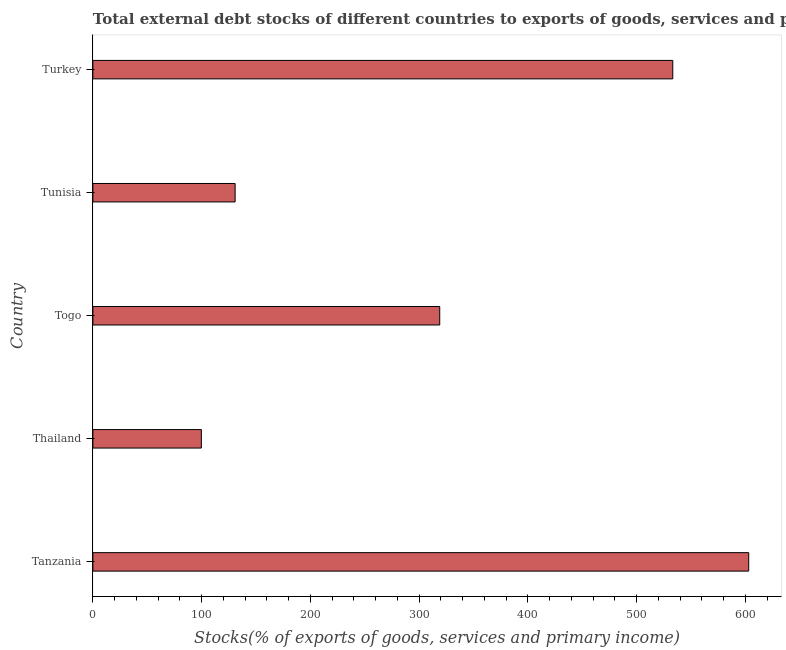Does the graph contain any zero values?
Your answer should be compact. No. What is the title of the graph?
Offer a very short reply. Total external debt stocks of different countries to exports of goods, services and primary income in 1979. What is the label or title of the X-axis?
Keep it short and to the point. Stocks(% of exports of goods, services and primary income). What is the label or title of the Y-axis?
Make the answer very short. Country. What is the external debt stocks in Thailand?
Your response must be concise. 99.73. Across all countries, what is the maximum external debt stocks?
Provide a short and direct response. 602.95. Across all countries, what is the minimum external debt stocks?
Your answer should be very brief. 99.73. In which country was the external debt stocks maximum?
Offer a very short reply. Tanzania. In which country was the external debt stocks minimum?
Ensure brevity in your answer.  Thailand. What is the sum of the external debt stocks?
Provide a short and direct response. 1685.51. What is the difference between the external debt stocks in Thailand and Togo?
Give a very brief answer. -219.16. What is the average external debt stocks per country?
Provide a succinct answer. 337.1. What is the median external debt stocks?
Keep it short and to the point. 318.89. In how many countries, is the external debt stocks greater than 140 %?
Your answer should be compact. 3. What is the ratio of the external debt stocks in Thailand to that in Togo?
Your answer should be very brief. 0.31. Is the external debt stocks in Tanzania less than that in Tunisia?
Give a very brief answer. No. What is the difference between the highest and the second highest external debt stocks?
Your answer should be compact. 69.8. What is the difference between the highest and the lowest external debt stocks?
Your answer should be compact. 503.22. Are all the bars in the graph horizontal?
Provide a succinct answer. Yes. How many countries are there in the graph?
Your answer should be compact. 5. What is the difference between two consecutive major ticks on the X-axis?
Your response must be concise. 100. Are the values on the major ticks of X-axis written in scientific E-notation?
Provide a succinct answer. No. What is the Stocks(% of exports of goods, services and primary income) in Tanzania?
Make the answer very short. 602.95. What is the Stocks(% of exports of goods, services and primary income) in Thailand?
Ensure brevity in your answer.  99.73. What is the Stocks(% of exports of goods, services and primary income) of Togo?
Your answer should be compact. 318.89. What is the Stocks(% of exports of goods, services and primary income) in Tunisia?
Provide a succinct answer. 130.78. What is the Stocks(% of exports of goods, services and primary income) of Turkey?
Ensure brevity in your answer.  533.16. What is the difference between the Stocks(% of exports of goods, services and primary income) in Tanzania and Thailand?
Provide a succinct answer. 503.22. What is the difference between the Stocks(% of exports of goods, services and primary income) in Tanzania and Togo?
Make the answer very short. 284.06. What is the difference between the Stocks(% of exports of goods, services and primary income) in Tanzania and Tunisia?
Offer a very short reply. 472.17. What is the difference between the Stocks(% of exports of goods, services and primary income) in Tanzania and Turkey?
Your response must be concise. 69.8. What is the difference between the Stocks(% of exports of goods, services and primary income) in Thailand and Togo?
Provide a succinct answer. -219.16. What is the difference between the Stocks(% of exports of goods, services and primary income) in Thailand and Tunisia?
Provide a succinct answer. -31.05. What is the difference between the Stocks(% of exports of goods, services and primary income) in Thailand and Turkey?
Your answer should be very brief. -433.42. What is the difference between the Stocks(% of exports of goods, services and primary income) in Togo and Tunisia?
Your answer should be compact. 188.11. What is the difference between the Stocks(% of exports of goods, services and primary income) in Togo and Turkey?
Make the answer very short. -214.27. What is the difference between the Stocks(% of exports of goods, services and primary income) in Tunisia and Turkey?
Offer a terse response. -402.38. What is the ratio of the Stocks(% of exports of goods, services and primary income) in Tanzania to that in Thailand?
Your answer should be compact. 6.05. What is the ratio of the Stocks(% of exports of goods, services and primary income) in Tanzania to that in Togo?
Offer a very short reply. 1.89. What is the ratio of the Stocks(% of exports of goods, services and primary income) in Tanzania to that in Tunisia?
Provide a short and direct response. 4.61. What is the ratio of the Stocks(% of exports of goods, services and primary income) in Tanzania to that in Turkey?
Offer a very short reply. 1.13. What is the ratio of the Stocks(% of exports of goods, services and primary income) in Thailand to that in Togo?
Keep it short and to the point. 0.31. What is the ratio of the Stocks(% of exports of goods, services and primary income) in Thailand to that in Tunisia?
Keep it short and to the point. 0.76. What is the ratio of the Stocks(% of exports of goods, services and primary income) in Thailand to that in Turkey?
Make the answer very short. 0.19. What is the ratio of the Stocks(% of exports of goods, services and primary income) in Togo to that in Tunisia?
Provide a short and direct response. 2.44. What is the ratio of the Stocks(% of exports of goods, services and primary income) in Togo to that in Turkey?
Your answer should be compact. 0.6. What is the ratio of the Stocks(% of exports of goods, services and primary income) in Tunisia to that in Turkey?
Make the answer very short. 0.24. 